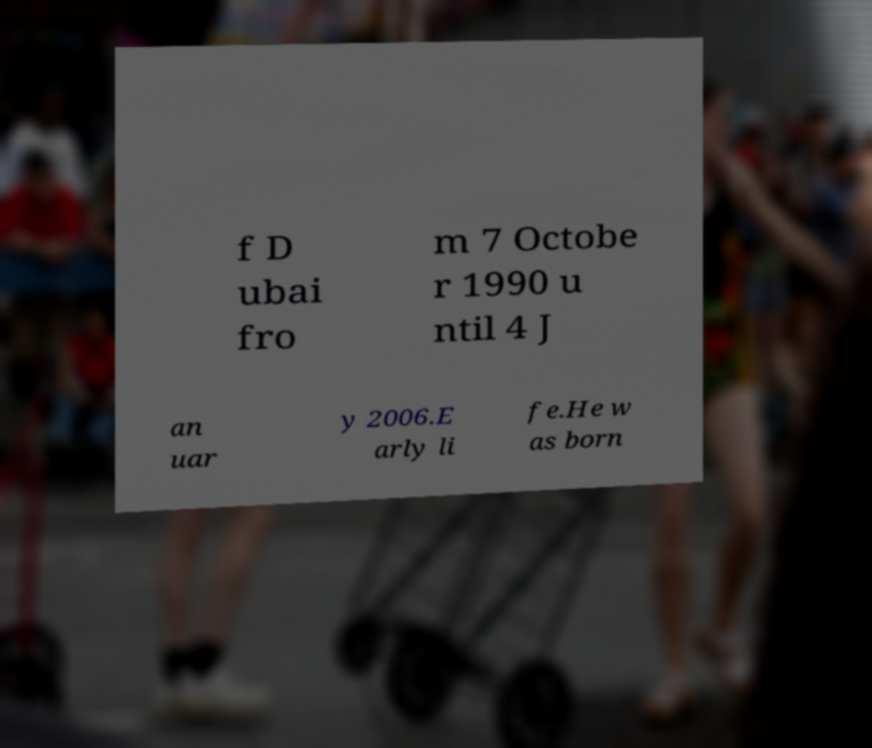What messages or text are displayed in this image? I need them in a readable, typed format. f D ubai fro m 7 Octobe r 1990 u ntil 4 J an uar y 2006.E arly li fe.He w as born 